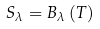Convert formula to latex. <formula><loc_0><loc_0><loc_500><loc_500>S _ { \lambda } = B _ { \lambda } \left ( T \right )</formula> 